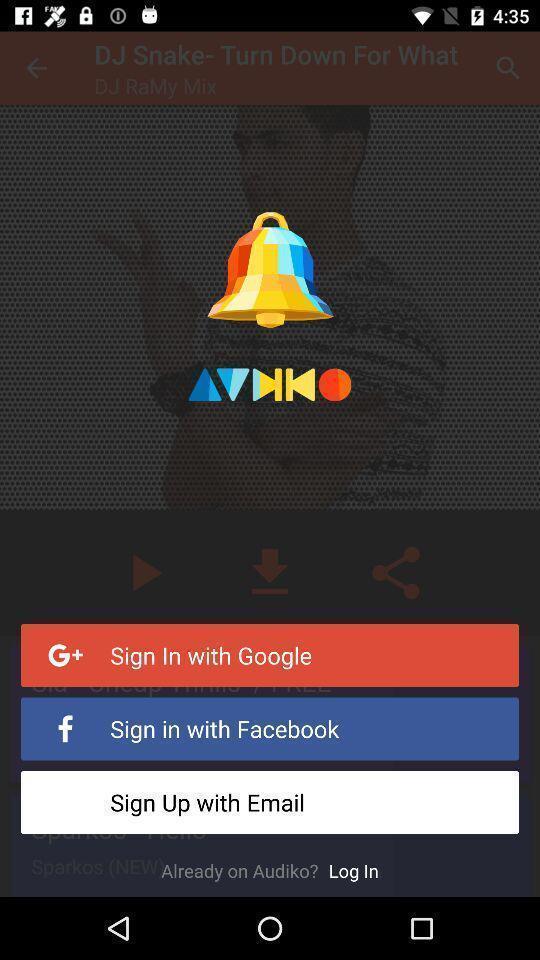Explain the elements present in this screenshot. Sign-in page. 